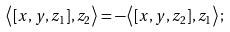Convert formula to latex. <formula><loc_0><loc_0><loc_500><loc_500>\left < [ x , y , z _ { 1 } ] , z _ { 2 } \right > = - \left < [ x , y , z _ { 2 } ] , z _ { 1 } \right > ;</formula> 